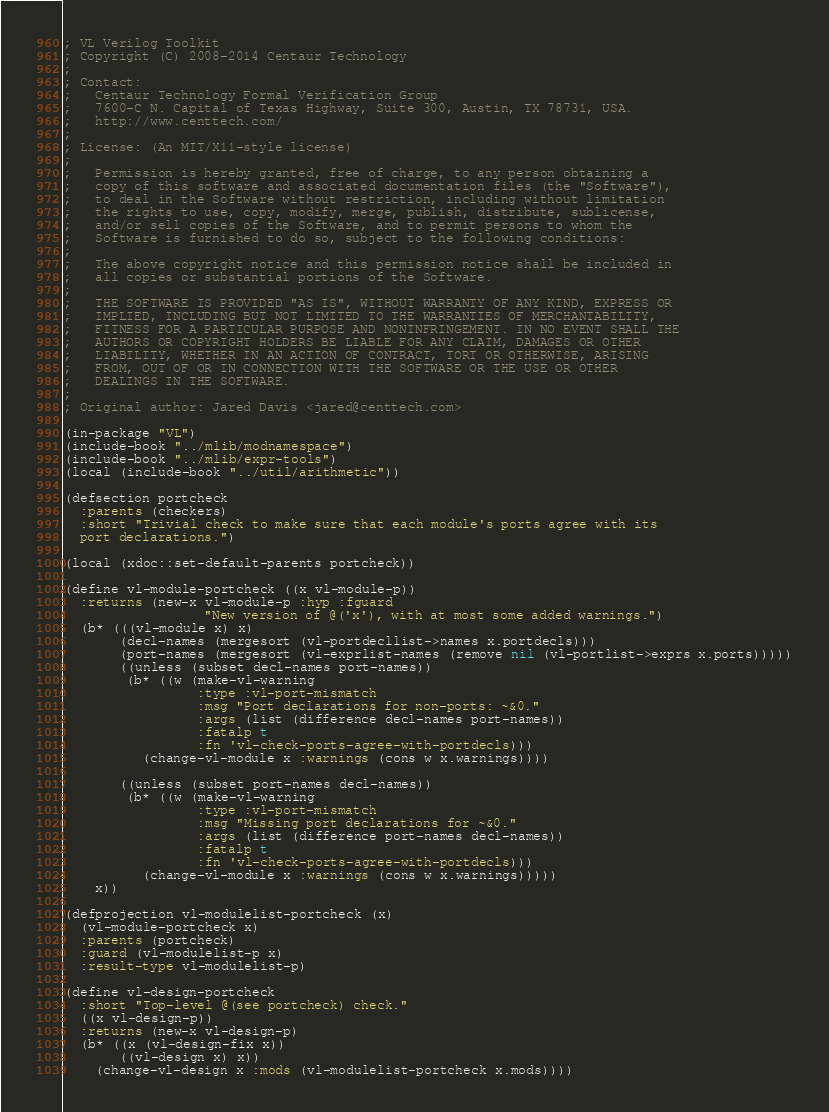Convert code to text. <code><loc_0><loc_0><loc_500><loc_500><_Lisp_>; VL Verilog Toolkit
; Copyright (C) 2008-2014 Centaur Technology
;
; Contact:
;   Centaur Technology Formal Verification Group
;   7600-C N. Capital of Texas Highway, Suite 300, Austin, TX 78731, USA.
;   http://www.centtech.com/
;
; License: (An MIT/X11-style license)
;
;   Permission is hereby granted, free of charge, to any person obtaining a
;   copy of this software and associated documentation files (the "Software"),
;   to deal in the Software without restriction, including without limitation
;   the rights to use, copy, modify, merge, publish, distribute, sublicense,
;   and/or sell copies of the Software, and to permit persons to whom the
;   Software is furnished to do so, subject to the following conditions:
;
;   The above copyright notice and this permission notice shall be included in
;   all copies or substantial portions of the Software.
;
;   THE SOFTWARE IS PROVIDED "AS IS", WITHOUT WARRANTY OF ANY KIND, EXPRESS OR
;   IMPLIED, INCLUDING BUT NOT LIMITED TO THE WARRANTIES OF MERCHANTABILITY,
;   FITNESS FOR A PARTICULAR PURPOSE AND NONINFRINGEMENT. IN NO EVENT SHALL THE
;   AUTHORS OR COPYRIGHT HOLDERS BE LIABLE FOR ANY CLAIM, DAMAGES OR OTHER
;   LIABILITY, WHETHER IN AN ACTION OF CONTRACT, TORT OR OTHERWISE, ARISING
;   FROM, OUT OF OR IN CONNECTION WITH THE SOFTWARE OR THE USE OR OTHER
;   DEALINGS IN THE SOFTWARE.
;
; Original author: Jared Davis <jared@centtech.com>

(in-package "VL")
(include-book "../mlib/modnamespace")
(include-book "../mlib/expr-tools")
(local (include-book "../util/arithmetic"))

(defsection portcheck
  :parents (checkers)
  :short "Trivial check to make sure that each module's ports agree with its
  port declarations.")

(local (xdoc::set-default-parents portcheck))

(define vl-module-portcheck ((x vl-module-p))
  :returns (new-x vl-module-p :hyp :fguard
                  "New version of @('x'), with at most some added warnings.")
  (b* (((vl-module x) x)
       (decl-names (mergesort (vl-portdecllist->names x.portdecls)))
       (port-names (mergesort (vl-exprlist-names (remove nil (vl-portlist->exprs x.ports)))))
       ((unless (subset decl-names port-names))
        (b* ((w (make-vl-warning
                 :type :vl-port-mismatch
                 :msg "Port declarations for non-ports: ~&0."
                 :args (list (difference decl-names port-names))
                 :fatalp t
                 :fn 'vl-check-ports-agree-with-portdecls)))
          (change-vl-module x :warnings (cons w x.warnings))))

       ((unless (subset port-names decl-names))
        (b* ((w (make-vl-warning
                 :type :vl-port-mismatch
                 :msg "Missing port declarations for ~&0."
                 :args (list (difference port-names decl-names))
                 :fatalp t
                 :fn 'vl-check-ports-agree-with-portdecls)))
          (change-vl-module x :warnings (cons w x.warnings)))))
    x))

(defprojection vl-modulelist-portcheck (x)
  (vl-module-portcheck x)
  :parents (portcheck)
  :guard (vl-modulelist-p x)
  :result-type vl-modulelist-p)

(define vl-design-portcheck
  :short "Top-level @(see portcheck) check."
  ((x vl-design-p))
  :returns (new-x vl-design-p)
  (b* ((x (vl-design-fix x))
       ((vl-design x) x))
    (change-vl-design x :mods (vl-modulelist-portcheck x.mods))))

</code> 